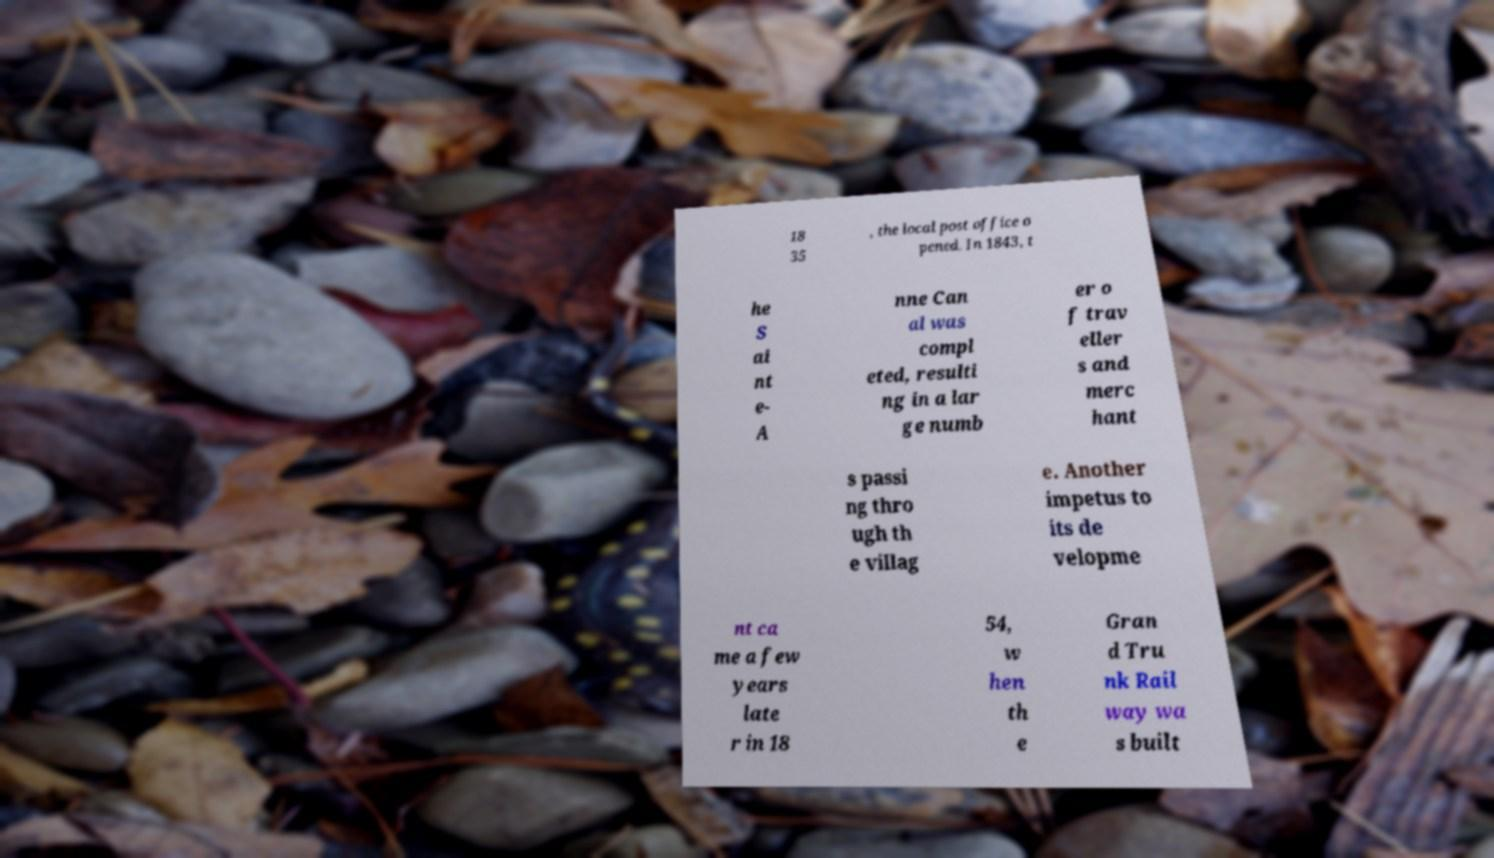What messages or text are displayed in this image? I need them in a readable, typed format. 18 35 , the local post office o pened. In 1843, t he S ai nt e- A nne Can al was compl eted, resulti ng in a lar ge numb er o f trav eller s and merc hant s passi ng thro ugh th e villag e. Another impetus to its de velopme nt ca me a few years late r in 18 54, w hen th e Gran d Tru nk Rail way wa s built 